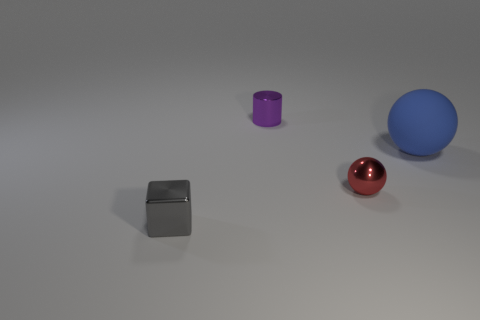Add 1 small spheres. How many objects exist? 5 Subtract all cylinders. How many objects are left? 3 Subtract 0 brown cylinders. How many objects are left? 4 Subtract all shiny balls. Subtract all red spheres. How many objects are left? 2 Add 1 small gray shiny objects. How many small gray shiny objects are left? 2 Add 2 metallic things. How many metallic things exist? 5 